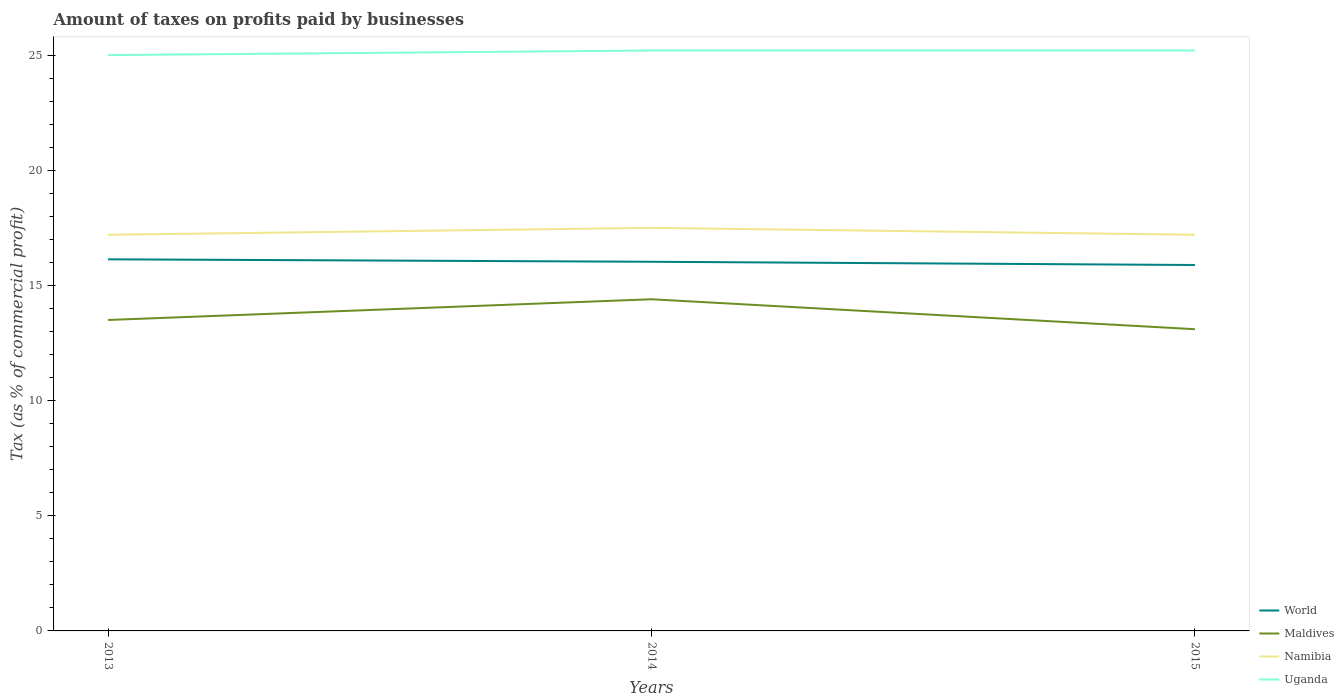How many different coloured lines are there?
Your response must be concise. 4. Does the line corresponding to World intersect with the line corresponding to Maldives?
Offer a very short reply. No. Is the number of lines equal to the number of legend labels?
Offer a very short reply. Yes. In which year was the percentage of taxes paid by businesses in World maximum?
Your answer should be very brief. 2015. What is the difference between the highest and the second highest percentage of taxes paid by businesses in Maldives?
Ensure brevity in your answer.  1.3. What is the difference between the highest and the lowest percentage of taxes paid by businesses in Uganda?
Provide a succinct answer. 2. Is the percentage of taxes paid by businesses in Maldives strictly greater than the percentage of taxes paid by businesses in Uganda over the years?
Provide a succinct answer. Yes. How many lines are there?
Your answer should be very brief. 4. Does the graph contain any zero values?
Provide a succinct answer. No. How many legend labels are there?
Your response must be concise. 4. How are the legend labels stacked?
Your response must be concise. Vertical. What is the title of the graph?
Offer a very short reply. Amount of taxes on profits paid by businesses. What is the label or title of the X-axis?
Keep it short and to the point. Years. What is the label or title of the Y-axis?
Provide a succinct answer. Tax (as % of commercial profit). What is the Tax (as % of commercial profit) of World in 2013?
Offer a very short reply. 16.13. What is the Tax (as % of commercial profit) of Namibia in 2013?
Your answer should be compact. 17.2. What is the Tax (as % of commercial profit) of World in 2014?
Your answer should be compact. 16.03. What is the Tax (as % of commercial profit) in Maldives in 2014?
Give a very brief answer. 14.4. What is the Tax (as % of commercial profit) of Namibia in 2014?
Give a very brief answer. 17.5. What is the Tax (as % of commercial profit) of Uganda in 2014?
Make the answer very short. 25.2. What is the Tax (as % of commercial profit) of World in 2015?
Provide a succinct answer. 15.89. What is the Tax (as % of commercial profit) of Maldives in 2015?
Your response must be concise. 13.1. What is the Tax (as % of commercial profit) in Uganda in 2015?
Provide a succinct answer. 25.2. Across all years, what is the maximum Tax (as % of commercial profit) of World?
Ensure brevity in your answer.  16.13. Across all years, what is the maximum Tax (as % of commercial profit) in Maldives?
Offer a terse response. 14.4. Across all years, what is the maximum Tax (as % of commercial profit) of Namibia?
Offer a terse response. 17.5. Across all years, what is the maximum Tax (as % of commercial profit) in Uganda?
Give a very brief answer. 25.2. Across all years, what is the minimum Tax (as % of commercial profit) of World?
Provide a short and direct response. 15.89. Across all years, what is the minimum Tax (as % of commercial profit) in Namibia?
Make the answer very short. 17.2. Across all years, what is the minimum Tax (as % of commercial profit) in Uganda?
Offer a terse response. 25. What is the total Tax (as % of commercial profit) in World in the graph?
Offer a terse response. 48.05. What is the total Tax (as % of commercial profit) in Namibia in the graph?
Make the answer very short. 51.9. What is the total Tax (as % of commercial profit) of Uganda in the graph?
Offer a terse response. 75.4. What is the difference between the Tax (as % of commercial profit) of World in 2013 and that in 2014?
Your response must be concise. 0.11. What is the difference between the Tax (as % of commercial profit) of Maldives in 2013 and that in 2014?
Your response must be concise. -0.9. What is the difference between the Tax (as % of commercial profit) in Namibia in 2013 and that in 2014?
Your response must be concise. -0.3. What is the difference between the Tax (as % of commercial profit) in Uganda in 2013 and that in 2014?
Make the answer very short. -0.2. What is the difference between the Tax (as % of commercial profit) in World in 2013 and that in 2015?
Ensure brevity in your answer.  0.25. What is the difference between the Tax (as % of commercial profit) of Namibia in 2013 and that in 2015?
Provide a succinct answer. 0. What is the difference between the Tax (as % of commercial profit) in World in 2014 and that in 2015?
Your answer should be very brief. 0.14. What is the difference between the Tax (as % of commercial profit) of Maldives in 2014 and that in 2015?
Provide a short and direct response. 1.3. What is the difference between the Tax (as % of commercial profit) in Namibia in 2014 and that in 2015?
Your response must be concise. 0.3. What is the difference between the Tax (as % of commercial profit) of World in 2013 and the Tax (as % of commercial profit) of Maldives in 2014?
Provide a short and direct response. 1.73. What is the difference between the Tax (as % of commercial profit) of World in 2013 and the Tax (as % of commercial profit) of Namibia in 2014?
Keep it short and to the point. -1.37. What is the difference between the Tax (as % of commercial profit) of World in 2013 and the Tax (as % of commercial profit) of Uganda in 2014?
Provide a succinct answer. -9.07. What is the difference between the Tax (as % of commercial profit) in Namibia in 2013 and the Tax (as % of commercial profit) in Uganda in 2014?
Keep it short and to the point. -8. What is the difference between the Tax (as % of commercial profit) of World in 2013 and the Tax (as % of commercial profit) of Maldives in 2015?
Give a very brief answer. 3.03. What is the difference between the Tax (as % of commercial profit) of World in 2013 and the Tax (as % of commercial profit) of Namibia in 2015?
Ensure brevity in your answer.  -1.07. What is the difference between the Tax (as % of commercial profit) in World in 2013 and the Tax (as % of commercial profit) in Uganda in 2015?
Your response must be concise. -9.07. What is the difference between the Tax (as % of commercial profit) of Maldives in 2013 and the Tax (as % of commercial profit) of Namibia in 2015?
Provide a succinct answer. -3.7. What is the difference between the Tax (as % of commercial profit) in World in 2014 and the Tax (as % of commercial profit) in Maldives in 2015?
Ensure brevity in your answer.  2.93. What is the difference between the Tax (as % of commercial profit) of World in 2014 and the Tax (as % of commercial profit) of Namibia in 2015?
Ensure brevity in your answer.  -1.17. What is the difference between the Tax (as % of commercial profit) of World in 2014 and the Tax (as % of commercial profit) of Uganda in 2015?
Your answer should be very brief. -9.17. What is the difference between the Tax (as % of commercial profit) in Maldives in 2014 and the Tax (as % of commercial profit) in Uganda in 2015?
Offer a very short reply. -10.8. What is the difference between the Tax (as % of commercial profit) in Namibia in 2014 and the Tax (as % of commercial profit) in Uganda in 2015?
Keep it short and to the point. -7.7. What is the average Tax (as % of commercial profit) in World per year?
Ensure brevity in your answer.  16.02. What is the average Tax (as % of commercial profit) of Maldives per year?
Give a very brief answer. 13.67. What is the average Tax (as % of commercial profit) in Uganda per year?
Ensure brevity in your answer.  25.13. In the year 2013, what is the difference between the Tax (as % of commercial profit) in World and Tax (as % of commercial profit) in Maldives?
Your answer should be compact. 2.63. In the year 2013, what is the difference between the Tax (as % of commercial profit) in World and Tax (as % of commercial profit) in Namibia?
Give a very brief answer. -1.07. In the year 2013, what is the difference between the Tax (as % of commercial profit) in World and Tax (as % of commercial profit) in Uganda?
Your response must be concise. -8.87. In the year 2013, what is the difference between the Tax (as % of commercial profit) of Maldives and Tax (as % of commercial profit) of Namibia?
Offer a very short reply. -3.7. In the year 2013, what is the difference between the Tax (as % of commercial profit) in Namibia and Tax (as % of commercial profit) in Uganda?
Ensure brevity in your answer.  -7.8. In the year 2014, what is the difference between the Tax (as % of commercial profit) in World and Tax (as % of commercial profit) in Maldives?
Keep it short and to the point. 1.63. In the year 2014, what is the difference between the Tax (as % of commercial profit) of World and Tax (as % of commercial profit) of Namibia?
Your response must be concise. -1.47. In the year 2014, what is the difference between the Tax (as % of commercial profit) in World and Tax (as % of commercial profit) in Uganda?
Provide a short and direct response. -9.17. In the year 2014, what is the difference between the Tax (as % of commercial profit) in Maldives and Tax (as % of commercial profit) in Uganda?
Your answer should be compact. -10.8. In the year 2014, what is the difference between the Tax (as % of commercial profit) of Namibia and Tax (as % of commercial profit) of Uganda?
Keep it short and to the point. -7.7. In the year 2015, what is the difference between the Tax (as % of commercial profit) of World and Tax (as % of commercial profit) of Maldives?
Your answer should be very brief. 2.79. In the year 2015, what is the difference between the Tax (as % of commercial profit) in World and Tax (as % of commercial profit) in Namibia?
Your answer should be very brief. -1.31. In the year 2015, what is the difference between the Tax (as % of commercial profit) of World and Tax (as % of commercial profit) of Uganda?
Provide a succinct answer. -9.31. In the year 2015, what is the difference between the Tax (as % of commercial profit) of Maldives and Tax (as % of commercial profit) of Namibia?
Make the answer very short. -4.1. In the year 2015, what is the difference between the Tax (as % of commercial profit) of Maldives and Tax (as % of commercial profit) of Uganda?
Keep it short and to the point. -12.1. What is the ratio of the Tax (as % of commercial profit) of World in 2013 to that in 2014?
Your answer should be compact. 1.01. What is the ratio of the Tax (as % of commercial profit) in Maldives in 2013 to that in 2014?
Offer a terse response. 0.94. What is the ratio of the Tax (as % of commercial profit) of Namibia in 2013 to that in 2014?
Ensure brevity in your answer.  0.98. What is the ratio of the Tax (as % of commercial profit) of World in 2013 to that in 2015?
Make the answer very short. 1.02. What is the ratio of the Tax (as % of commercial profit) of Maldives in 2013 to that in 2015?
Provide a short and direct response. 1.03. What is the ratio of the Tax (as % of commercial profit) of Namibia in 2013 to that in 2015?
Make the answer very short. 1. What is the ratio of the Tax (as % of commercial profit) in Uganda in 2013 to that in 2015?
Ensure brevity in your answer.  0.99. What is the ratio of the Tax (as % of commercial profit) in World in 2014 to that in 2015?
Make the answer very short. 1.01. What is the ratio of the Tax (as % of commercial profit) of Maldives in 2014 to that in 2015?
Provide a succinct answer. 1.1. What is the ratio of the Tax (as % of commercial profit) in Namibia in 2014 to that in 2015?
Your answer should be compact. 1.02. What is the ratio of the Tax (as % of commercial profit) of Uganda in 2014 to that in 2015?
Give a very brief answer. 1. What is the difference between the highest and the second highest Tax (as % of commercial profit) in World?
Keep it short and to the point. 0.11. What is the difference between the highest and the second highest Tax (as % of commercial profit) of Namibia?
Your answer should be compact. 0.3. What is the difference between the highest and the second highest Tax (as % of commercial profit) in Uganda?
Give a very brief answer. 0. What is the difference between the highest and the lowest Tax (as % of commercial profit) in World?
Ensure brevity in your answer.  0.25. What is the difference between the highest and the lowest Tax (as % of commercial profit) of Uganda?
Offer a terse response. 0.2. 